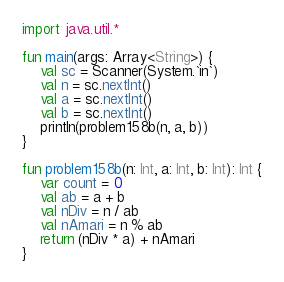Convert code to text. <code><loc_0><loc_0><loc_500><loc_500><_Kotlin_>import java.util.*

fun main(args: Array<String>) {
    val sc = Scanner(System.`in`)
    val n = sc.nextInt()
    val a = sc.nextInt()
    val b = sc.nextInt()
    println(problem158b(n, a, b))
}

fun problem158b(n: Int, a: Int, b: Int): Int {
    var count = 0
    val ab = a + b
    val nDiv = n / ab
    val nAmari = n % ab
    return (nDiv * a) + nAmari
}</code> 